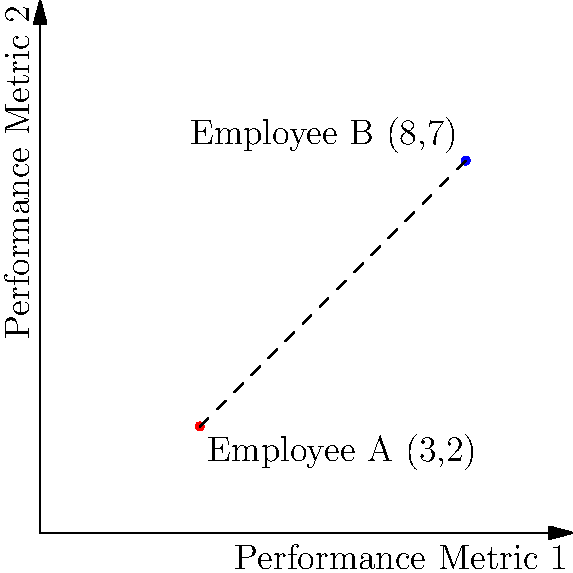In a performance evaluation system, two employees' metrics are plotted on a coordinate plane. Employee A's performance is represented by the point (3,2), while Employee B's performance is at (8,7). Calculate the Euclidean distance between these two points to determine the difference in their overall performance. How might this distance metric be ethically interpreted in the context of employee evaluation? To solve this problem, we'll follow these steps:

1. Recall the distance formula between two points $(x_1, y_1)$ and $(x_2, y_2)$:
   $$d = \sqrt{(x_2 - x_1)^2 + (y_2 - y_1)^2}$$

2. Identify the coordinates:
   Employee A: $(x_1, y_1) = (3, 2)$
   Employee B: $(x_2, y_2) = (8, 7)$

3. Substitute these values into the formula:
   $$d = \sqrt{(8 - 3)^2 + (7 - 2)^2}$$

4. Simplify:
   $$d = \sqrt{5^2 + 5^2} = \sqrt{25 + 25} = \sqrt{50}$$

5. Simplify the square root:
   $$d = 5\sqrt{2} \approx 7.07$$

The Euclidean distance between the two points is $5\sqrt{2}$ or approximately 7.07 units.

Ethical interpretation:
1. This distance provides a quantitative measure of the difference in performance between the two employees.
2. However, it's crucial to consider that this metric may oversimplify complex performance factors.
3. Ethical considerations include:
   - Ensuring that the metrics used are fair and relevant to job performance.
   - Avoiding bias in the selection and weighting of performance criteria.
   - Recognizing that employees may excel in different areas, and a single distance metric may not capture these nuances.
   - Using this metric as one part of a holistic evaluation process, rather than the sole determinant of performance.
   - Providing opportunities for employees to improve and bridging performance gaps through training and support.
4. From a philosophical perspective, one might consider utilitarian (maximizing overall productivity) vs. deontological (respecting individual dignity and fairness) approaches to using such metrics.
5. Transparency in how these metrics are calculated and used is crucial for maintaining trust and ethical standards in performance evaluation.
Answer: $5\sqrt{2}$ units; ethical use requires holistic interpretation, fairness, and transparency. 